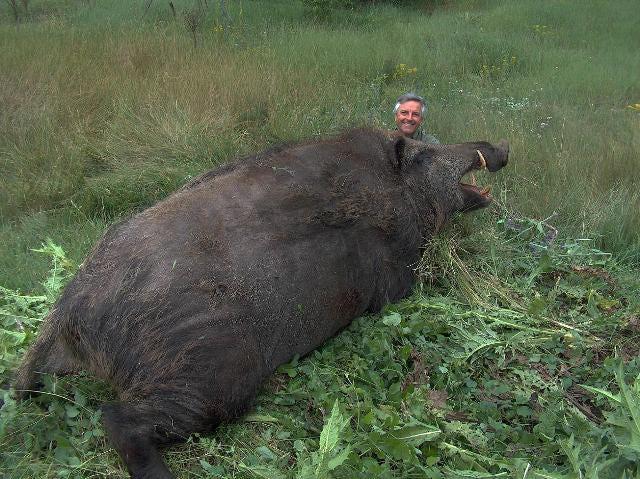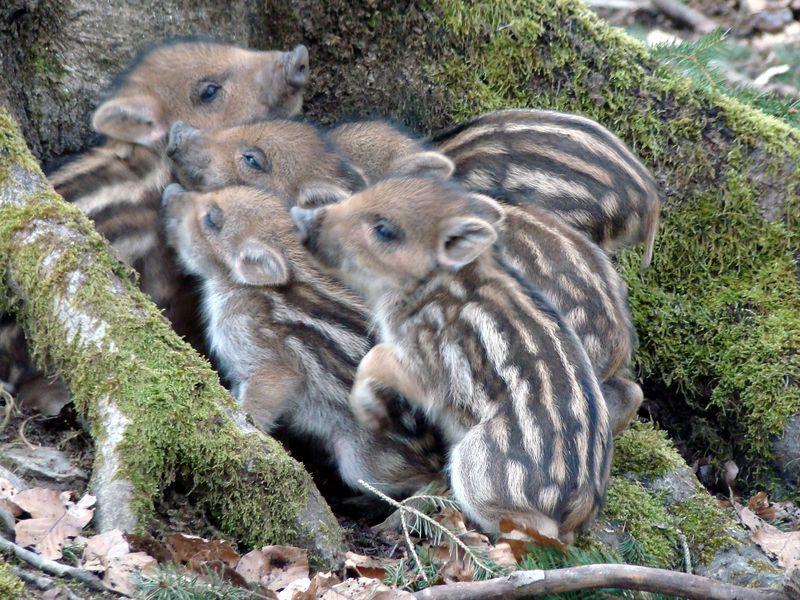The first image is the image on the left, the second image is the image on the right. For the images displayed, is the sentence "A man with a gun poses behind a downed boar in the right image." factually correct? Answer yes or no. No. 